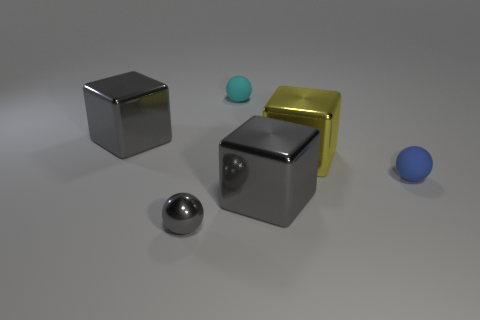Is the number of tiny cyan matte objects greater than the number of gray things?
Offer a very short reply. No. Does the tiny cyan sphere have the same material as the yellow block?
Keep it short and to the point. No. How many tiny cyan objects have the same material as the small gray ball?
Offer a very short reply. 0. Is the size of the gray metal sphere the same as the metallic cube to the left of the small metal ball?
Keep it short and to the point. No. What is the color of the small sphere that is to the left of the large yellow shiny object and behind the small shiny ball?
Give a very brief answer. Cyan. There is a matte ball that is left of the yellow thing; are there any cubes that are on the right side of it?
Make the answer very short. Yes. Are there the same number of gray metal objects that are on the right side of the blue rubber sphere and large purple cylinders?
Your response must be concise. Yes. How many big gray blocks are on the right side of the small thing that is in front of the big gray block in front of the small blue matte ball?
Offer a terse response. 1. Is there a blue metal cube of the same size as the cyan matte object?
Keep it short and to the point. No. Is the number of tiny blue balls left of the small cyan ball less than the number of small cyan spheres?
Offer a terse response. Yes. 